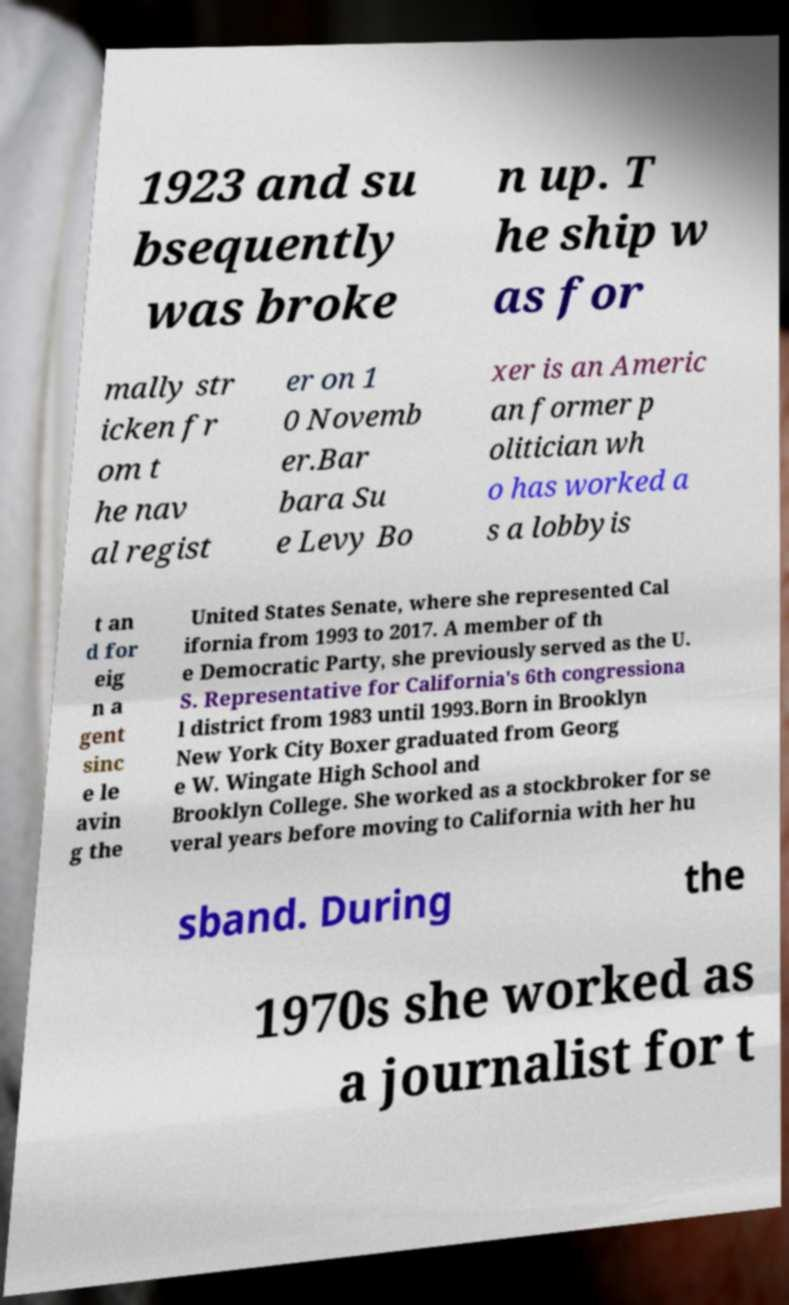Could you extract and type out the text from this image? 1923 and su bsequently was broke n up. T he ship w as for mally str icken fr om t he nav al regist er on 1 0 Novemb er.Bar bara Su e Levy Bo xer is an Americ an former p olitician wh o has worked a s a lobbyis t an d for eig n a gent sinc e le avin g the United States Senate, where she represented Cal ifornia from 1993 to 2017. A member of th e Democratic Party, she previously served as the U. S. Representative for California's 6th congressiona l district from 1983 until 1993.Born in Brooklyn New York City Boxer graduated from Georg e W. Wingate High School and Brooklyn College. She worked as a stockbroker for se veral years before moving to California with her hu sband. During the 1970s she worked as a journalist for t 